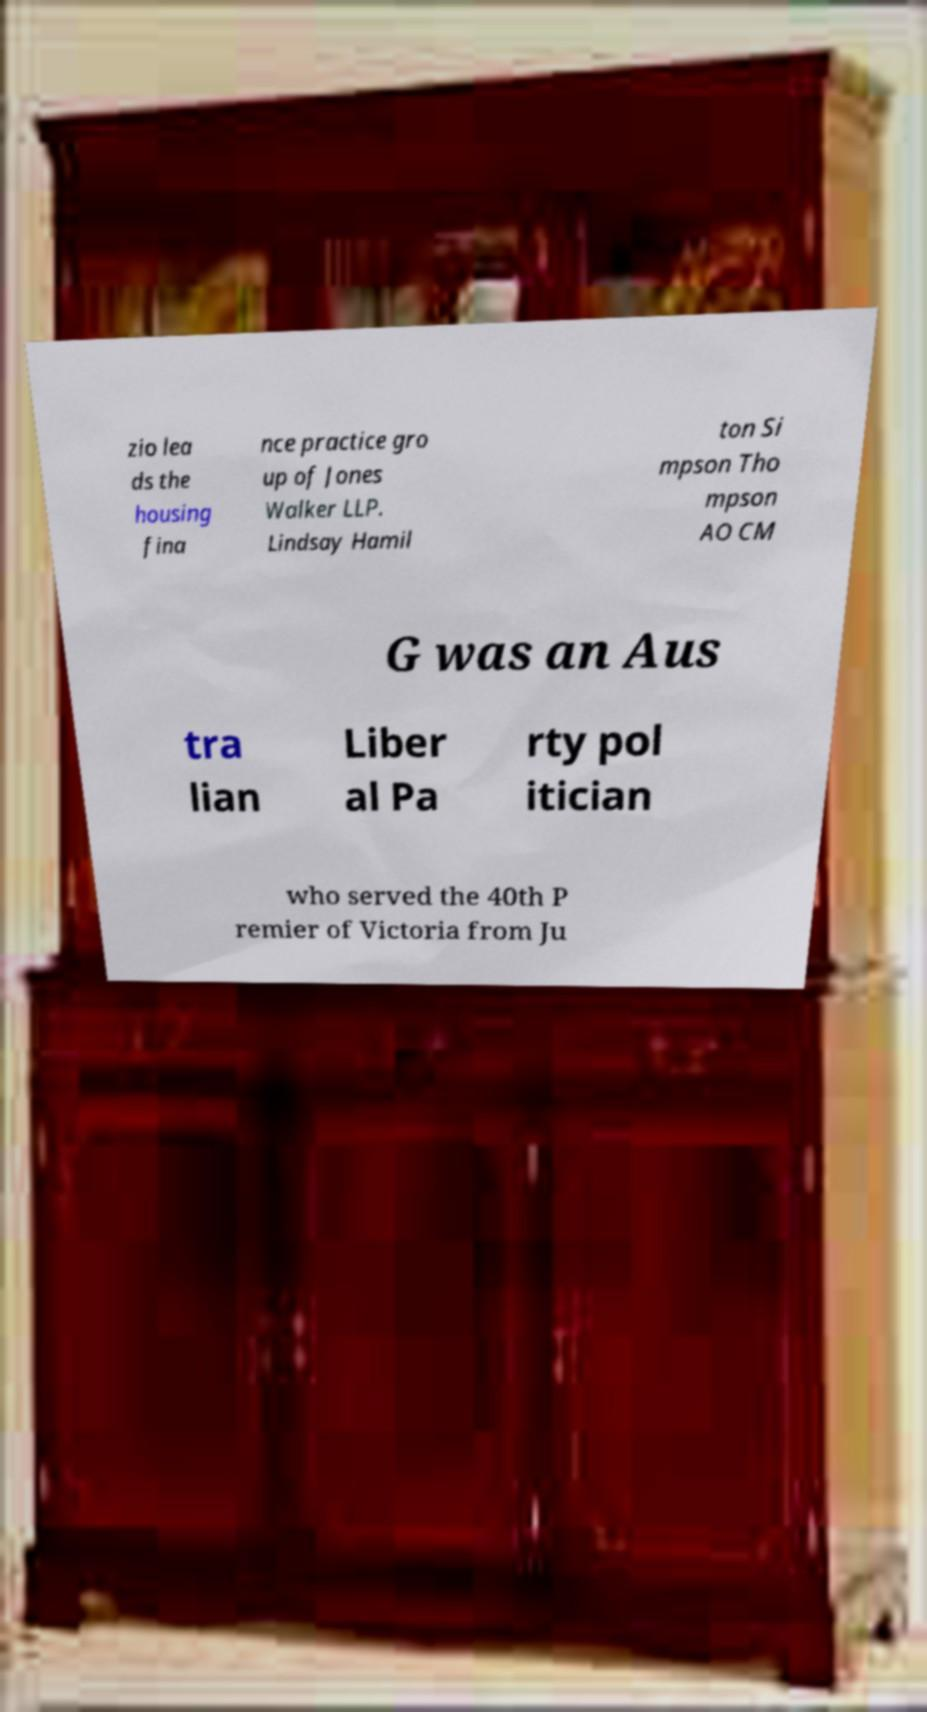For documentation purposes, I need the text within this image transcribed. Could you provide that? zio lea ds the housing fina nce practice gro up of Jones Walker LLP. Lindsay Hamil ton Si mpson Tho mpson AO CM G was an Aus tra lian Liber al Pa rty pol itician who served the 40th P remier of Victoria from Ju 